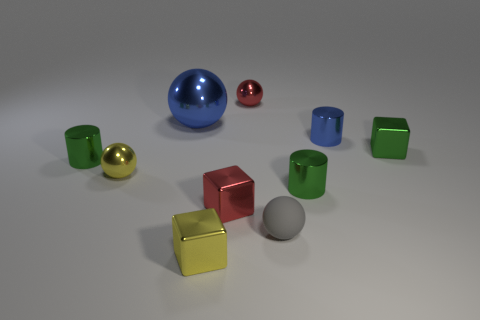Subtract all cylinders. How many objects are left? 7 Subtract 0 purple balls. How many objects are left? 10 Subtract all large blue rubber things. Subtract all spheres. How many objects are left? 6 Add 6 gray matte spheres. How many gray matte spheres are left? 7 Add 3 large blue shiny cubes. How many large blue shiny cubes exist? 3 